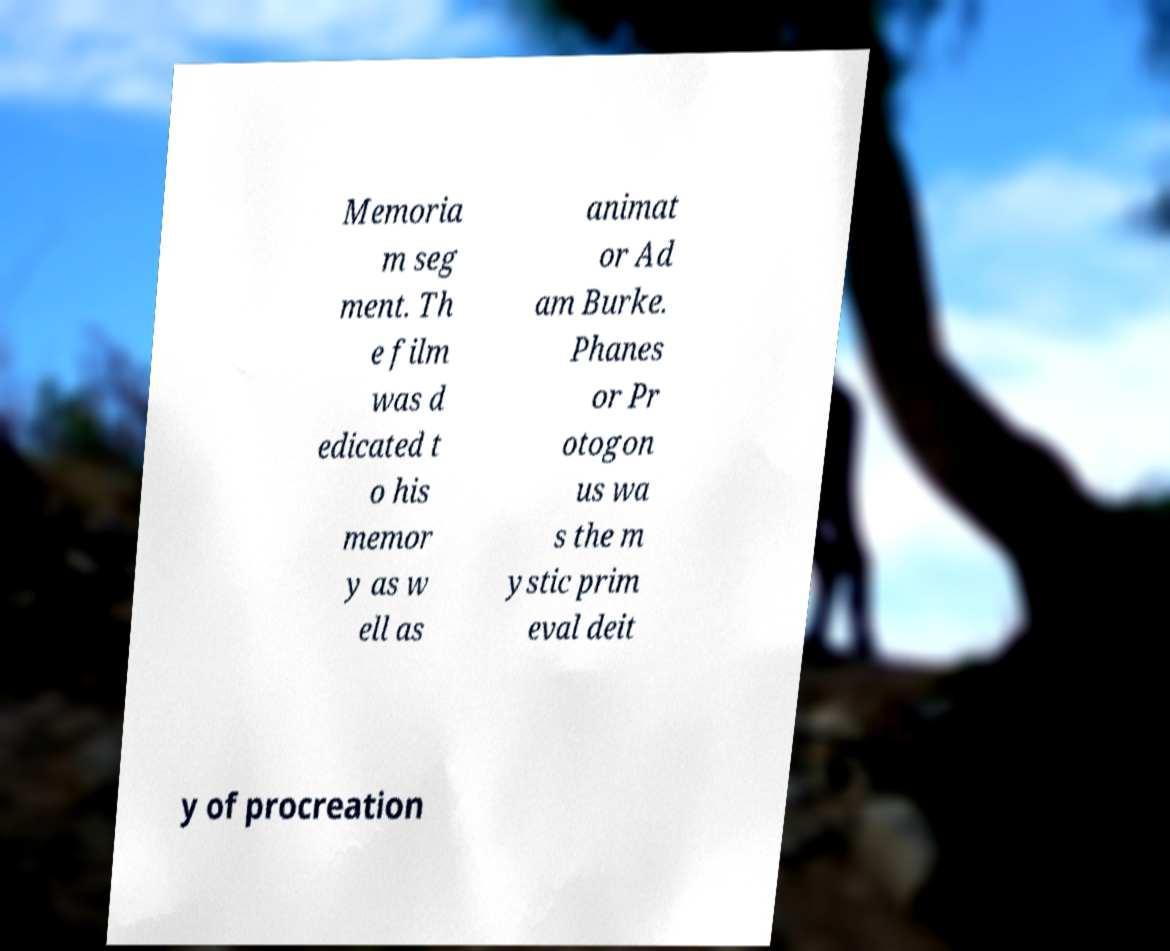Can you accurately transcribe the text from the provided image for me? Memoria m seg ment. Th e film was d edicated t o his memor y as w ell as animat or Ad am Burke. Phanes or Pr otogon us wa s the m ystic prim eval deit y of procreation 